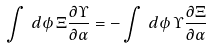<formula> <loc_0><loc_0><loc_500><loc_500>\int \, d \phi \, \Xi \frac { \partial \Upsilon } { \partial \alpha } = - \int \, d \phi \, \Upsilon \frac { \partial \Xi } { \partial \alpha }</formula> 